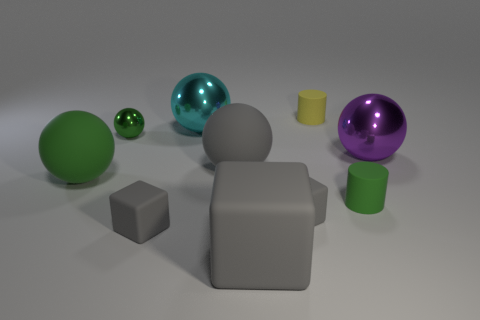Can you describe the texture and finish of the objects in the foreground? Certainly! The objects in the foreground have a matte finish with a smooth texture, specifically the gray cube and the gray cylinder. 